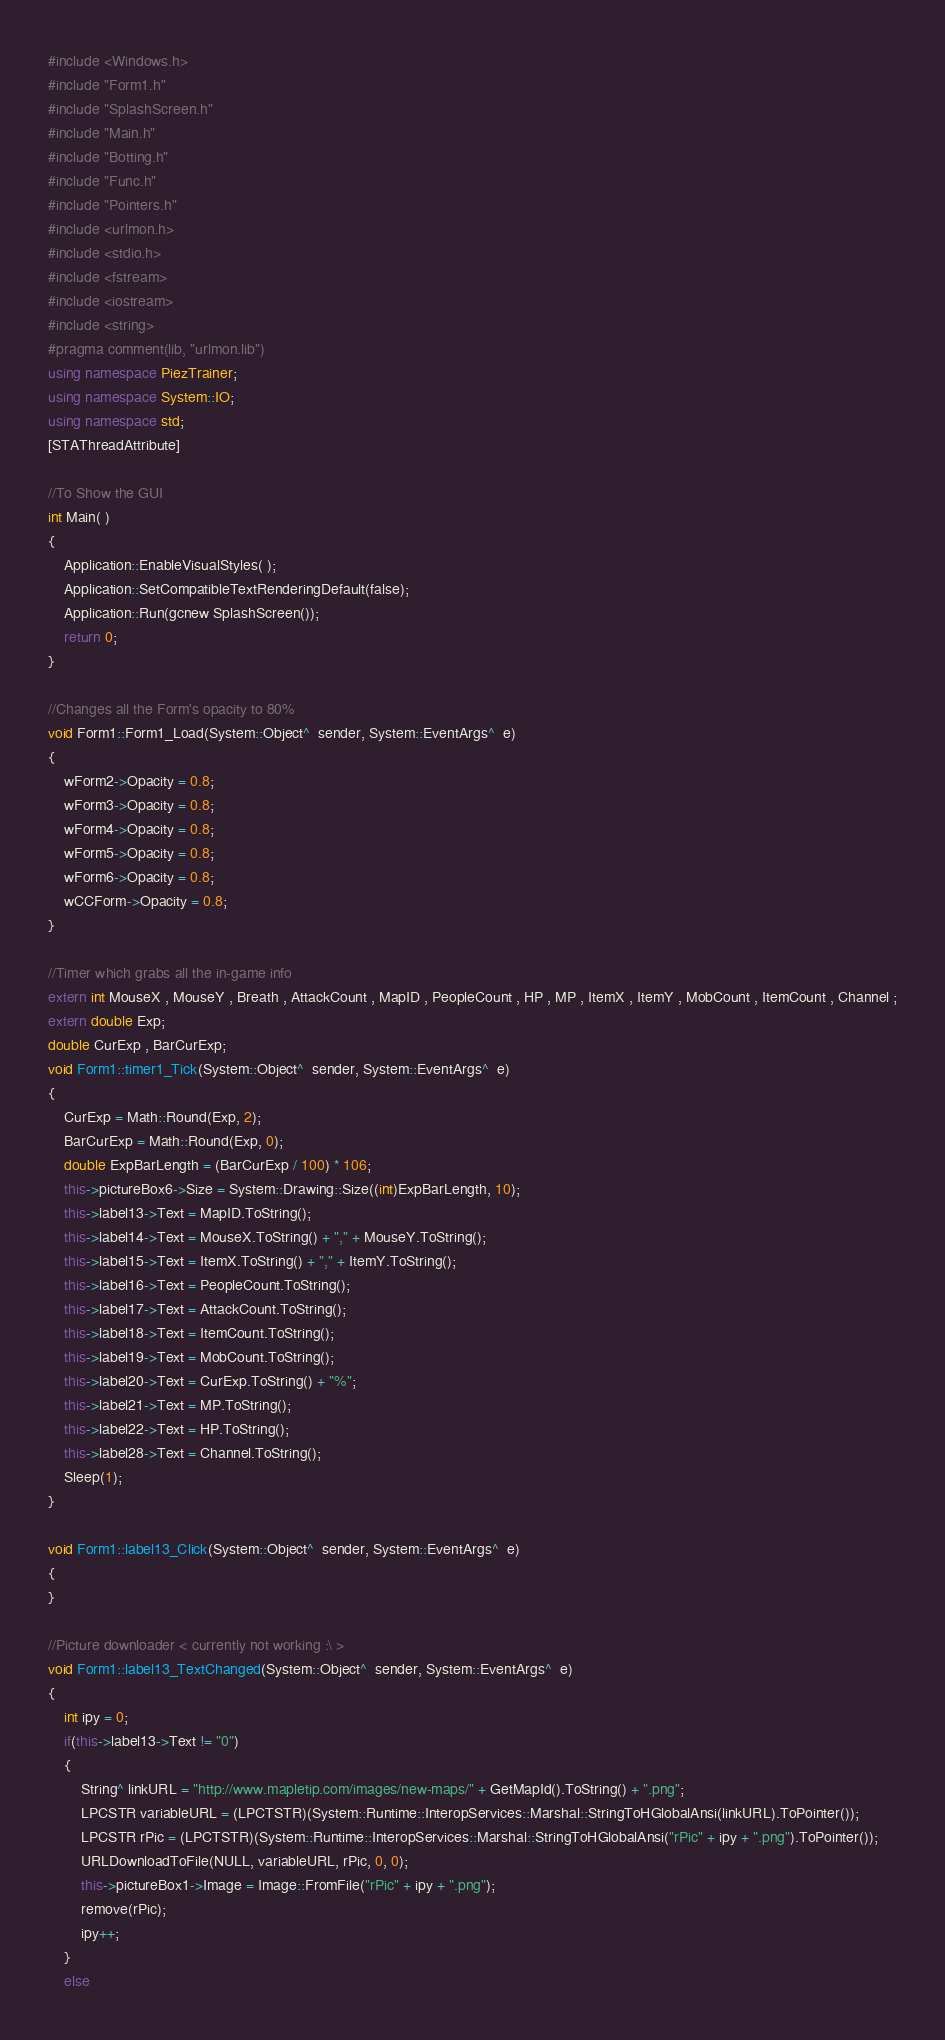Convert code to text. <code><loc_0><loc_0><loc_500><loc_500><_C++_>#include <Windows.h>
#include "Form1.h"
#include "SplashScreen.h"
#include "Main.h"
#include "Botting.h"
#include "Func.h"
#include "Pointers.h"
#include <urlmon.h>
#include <stdio.h>
#include <fstream>
#include <iostream>
#include <string>
#pragma comment(lib, "urlmon.lib")
using namespace PiezTrainer;
using namespace System::IO;
using namespace std;
[STAThreadAttribute]

//To Show the GUI
int Main( )
{
    Application::EnableVisualStyles( );
    Application::SetCompatibleTextRenderingDefault(false); 
    Application::Run(gcnew SplashScreen());
    return 0;
}

//Changes all the Form's opacity to 80%
void Form1::Form1_Load(System::Object^  sender, System::EventArgs^  e)
{
	wForm2->Opacity = 0.8;
	wForm3->Opacity = 0.8;
	wForm4->Opacity = 0.8;
	wForm5->Opacity = 0.8;
	wForm6->Opacity = 0.8;
	wCCForm->Opacity = 0.8;
}

//Timer which grabs all the in-game info
extern int MouseX , MouseY , Breath , AttackCount , MapID , PeopleCount , HP , MP , ItemX , ItemY , MobCount , ItemCount , Channel ;
extern double Exp;
double CurExp , BarCurExp;
void Form1::timer1_Tick(System::Object^  sender, System::EventArgs^  e)
{
	CurExp = Math::Round(Exp, 2);
	BarCurExp = Math::Round(Exp, 0);
	double ExpBarLength = (BarCurExp / 100) * 106;
	this->pictureBox6->Size = System::Drawing::Size((int)ExpBarLength, 10);
	this->label13->Text = MapID.ToString();
	this->label14->Text = MouseX.ToString() + "," + MouseY.ToString();
	this->label15->Text = ItemX.ToString() + "," + ItemY.ToString();
	this->label16->Text = PeopleCount.ToString();
	this->label17->Text = AttackCount.ToString();
	this->label18->Text = ItemCount.ToString();
	this->label19->Text = MobCount.ToString();
	this->label20->Text = CurExp.ToString() + "%";
	this->label21->Text = MP.ToString();
	this->label22->Text = HP.ToString();
	this->label28->Text = Channel.ToString();
	Sleep(1);
}

void Form1::label13_Click(System::Object^  sender, System::EventArgs^  e)
{
}

//Picture downloader < currently not working :\ >
void Form1::label13_TextChanged(System::Object^  sender, System::EventArgs^  e)
{
	int ipy = 0;
	if(this->label13->Text != "0")
	{
		String^ linkURL = "http://www.mapletip.com/images/new-maps/" + GetMapId().ToString() + ".png";
		LPCSTR variableURL = (LPCTSTR)(System::Runtime::InteropServices::Marshal::StringToHGlobalAnsi(linkURL).ToPointer());
		LPCSTR rPic = (LPCTSTR)(System::Runtime::InteropServices::Marshal::StringToHGlobalAnsi("rPic" + ipy + ".png").ToPointer());
		URLDownloadToFile(NULL, variableURL, rPic, 0, 0);
		this->pictureBox1->Image = Image::FromFile("rPic" + ipy + ".png");
		remove(rPic);
		ipy++;
	}
	else</code> 